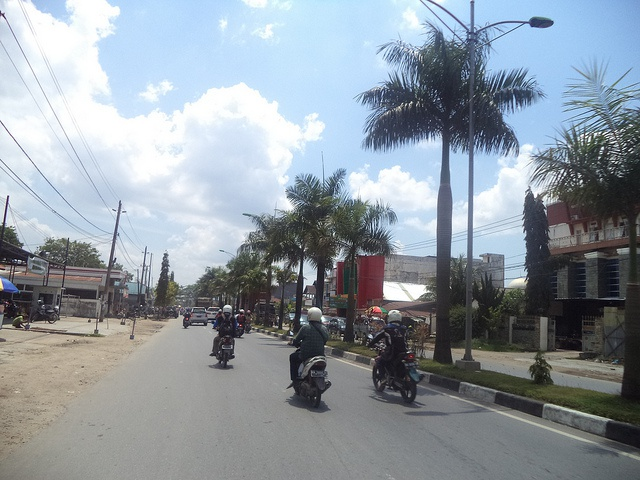Describe the objects in this image and their specific colors. I can see motorcycle in lightgray, black, gray, and darkgreen tones, people in lightgray, black, gray, and darkgray tones, people in lightgray, black, gray, and darkgray tones, motorcycle in lightgray, black, gray, and darkgray tones, and people in lightgray, black, gray, and navy tones in this image. 